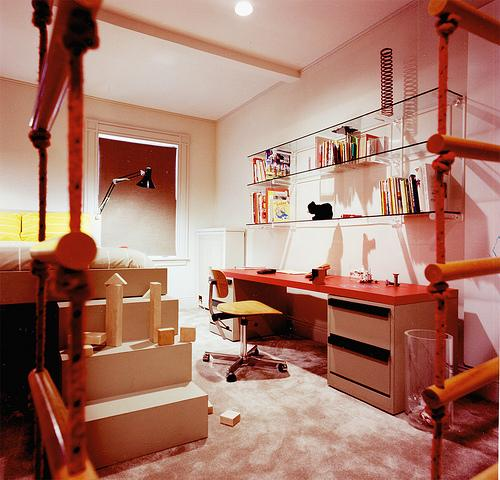Who uses this room? child 